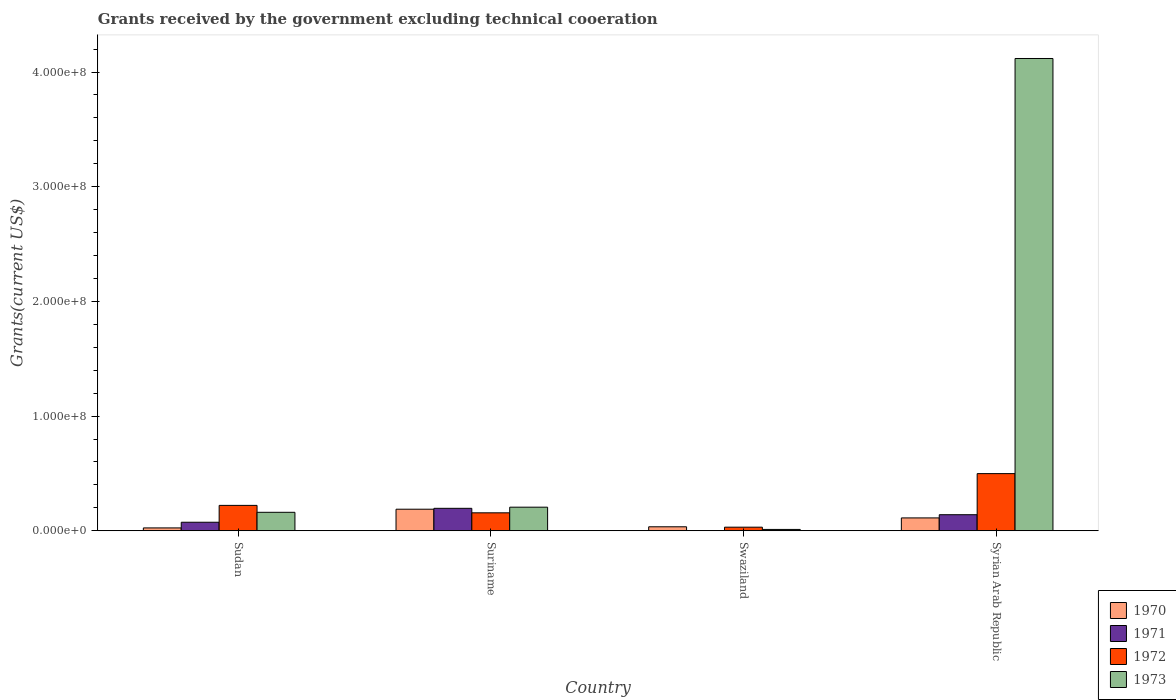How many different coloured bars are there?
Keep it short and to the point. 4. Are the number of bars per tick equal to the number of legend labels?
Your answer should be very brief. No. Are the number of bars on each tick of the X-axis equal?
Keep it short and to the point. No. How many bars are there on the 3rd tick from the left?
Provide a short and direct response. 3. How many bars are there on the 2nd tick from the right?
Keep it short and to the point. 3. What is the label of the 3rd group of bars from the left?
Provide a succinct answer. Swaziland. What is the total grants received by the government in 1973 in Syrian Arab Republic?
Your answer should be very brief. 4.12e+08. Across all countries, what is the maximum total grants received by the government in 1971?
Offer a terse response. 1.96e+07. Across all countries, what is the minimum total grants received by the government in 1972?
Give a very brief answer. 3.14e+06. In which country was the total grants received by the government in 1972 maximum?
Give a very brief answer. Syrian Arab Republic. What is the total total grants received by the government in 1970 in the graph?
Offer a terse response. 3.60e+07. What is the difference between the total grants received by the government in 1970 in Sudan and that in Swaziland?
Your answer should be very brief. -9.90e+05. What is the difference between the total grants received by the government in 1970 in Sudan and the total grants received by the government in 1972 in Syrian Arab Republic?
Your answer should be very brief. -4.74e+07. What is the average total grants received by the government in 1972 per country?
Keep it short and to the point. 2.27e+07. What is the difference between the total grants received by the government of/in 1970 and total grants received by the government of/in 1971 in Sudan?
Make the answer very short. -4.95e+06. What is the ratio of the total grants received by the government in 1970 in Sudan to that in Swaziland?
Ensure brevity in your answer.  0.72. Is the difference between the total grants received by the government in 1970 in Sudan and Syrian Arab Republic greater than the difference between the total grants received by the government in 1971 in Sudan and Syrian Arab Republic?
Provide a short and direct response. No. What is the difference between the highest and the second highest total grants received by the government in 1970?
Provide a succinct answer. 7.58e+06. What is the difference between the highest and the lowest total grants received by the government in 1971?
Your answer should be compact. 1.96e+07. Is the sum of the total grants received by the government in 1970 in Sudan and Swaziland greater than the maximum total grants received by the government in 1973 across all countries?
Make the answer very short. No. Are all the bars in the graph horizontal?
Keep it short and to the point. No. What is the difference between two consecutive major ticks on the Y-axis?
Your answer should be very brief. 1.00e+08. What is the title of the graph?
Keep it short and to the point. Grants received by the government excluding technical cooeration. What is the label or title of the Y-axis?
Give a very brief answer. Grants(current US$). What is the Grants(current US$) in 1970 in Sudan?
Your response must be concise. 2.50e+06. What is the Grants(current US$) in 1971 in Sudan?
Offer a terse response. 7.45e+06. What is the Grants(current US$) in 1972 in Sudan?
Offer a very short reply. 2.22e+07. What is the Grants(current US$) in 1973 in Sudan?
Make the answer very short. 1.61e+07. What is the Grants(current US$) of 1970 in Suriname?
Provide a short and direct response. 1.88e+07. What is the Grants(current US$) of 1971 in Suriname?
Provide a short and direct response. 1.96e+07. What is the Grants(current US$) in 1972 in Suriname?
Ensure brevity in your answer.  1.57e+07. What is the Grants(current US$) of 1973 in Suriname?
Offer a very short reply. 2.06e+07. What is the Grants(current US$) in 1970 in Swaziland?
Offer a terse response. 3.49e+06. What is the Grants(current US$) in 1972 in Swaziland?
Give a very brief answer. 3.14e+06. What is the Grants(current US$) in 1973 in Swaziland?
Your response must be concise. 1.18e+06. What is the Grants(current US$) of 1970 in Syrian Arab Republic?
Offer a very short reply. 1.12e+07. What is the Grants(current US$) in 1971 in Syrian Arab Republic?
Provide a short and direct response. 1.40e+07. What is the Grants(current US$) of 1972 in Syrian Arab Republic?
Give a very brief answer. 4.98e+07. What is the Grants(current US$) in 1973 in Syrian Arab Republic?
Ensure brevity in your answer.  4.12e+08. Across all countries, what is the maximum Grants(current US$) in 1970?
Provide a short and direct response. 1.88e+07. Across all countries, what is the maximum Grants(current US$) in 1971?
Your response must be concise. 1.96e+07. Across all countries, what is the maximum Grants(current US$) of 1972?
Your response must be concise. 4.98e+07. Across all countries, what is the maximum Grants(current US$) in 1973?
Give a very brief answer. 4.12e+08. Across all countries, what is the minimum Grants(current US$) in 1970?
Make the answer very short. 2.50e+06. Across all countries, what is the minimum Grants(current US$) in 1972?
Offer a very short reply. 3.14e+06. Across all countries, what is the minimum Grants(current US$) of 1973?
Keep it short and to the point. 1.18e+06. What is the total Grants(current US$) in 1970 in the graph?
Make the answer very short. 3.60e+07. What is the total Grants(current US$) of 1971 in the graph?
Keep it short and to the point. 4.10e+07. What is the total Grants(current US$) in 1972 in the graph?
Your response must be concise. 9.08e+07. What is the total Grants(current US$) of 1973 in the graph?
Your response must be concise. 4.50e+08. What is the difference between the Grants(current US$) of 1970 in Sudan and that in Suriname?
Your response must be concise. -1.63e+07. What is the difference between the Grants(current US$) in 1971 in Sudan and that in Suriname?
Offer a terse response. -1.21e+07. What is the difference between the Grants(current US$) of 1972 in Sudan and that in Suriname?
Make the answer very short. 6.49e+06. What is the difference between the Grants(current US$) in 1973 in Sudan and that in Suriname?
Offer a terse response. -4.46e+06. What is the difference between the Grants(current US$) in 1970 in Sudan and that in Swaziland?
Make the answer very short. -9.90e+05. What is the difference between the Grants(current US$) of 1972 in Sudan and that in Swaziland?
Ensure brevity in your answer.  1.90e+07. What is the difference between the Grants(current US$) of 1973 in Sudan and that in Swaziland?
Your answer should be compact. 1.49e+07. What is the difference between the Grants(current US$) of 1970 in Sudan and that in Syrian Arab Republic?
Your answer should be compact. -8.73e+06. What is the difference between the Grants(current US$) of 1971 in Sudan and that in Syrian Arab Republic?
Give a very brief answer. -6.56e+06. What is the difference between the Grants(current US$) of 1972 in Sudan and that in Syrian Arab Republic?
Offer a very short reply. -2.77e+07. What is the difference between the Grants(current US$) of 1973 in Sudan and that in Syrian Arab Republic?
Offer a very short reply. -3.96e+08. What is the difference between the Grants(current US$) of 1970 in Suriname and that in Swaziland?
Provide a succinct answer. 1.53e+07. What is the difference between the Grants(current US$) in 1972 in Suriname and that in Swaziland?
Keep it short and to the point. 1.25e+07. What is the difference between the Grants(current US$) in 1973 in Suriname and that in Swaziland?
Offer a very short reply. 1.94e+07. What is the difference between the Grants(current US$) of 1970 in Suriname and that in Syrian Arab Republic?
Offer a very short reply. 7.58e+06. What is the difference between the Grants(current US$) of 1971 in Suriname and that in Syrian Arab Republic?
Your response must be concise. 5.58e+06. What is the difference between the Grants(current US$) of 1972 in Suriname and that in Syrian Arab Republic?
Your answer should be compact. -3.42e+07. What is the difference between the Grants(current US$) in 1973 in Suriname and that in Syrian Arab Republic?
Keep it short and to the point. -3.91e+08. What is the difference between the Grants(current US$) in 1970 in Swaziland and that in Syrian Arab Republic?
Ensure brevity in your answer.  -7.74e+06. What is the difference between the Grants(current US$) in 1972 in Swaziland and that in Syrian Arab Republic?
Give a very brief answer. -4.67e+07. What is the difference between the Grants(current US$) in 1973 in Swaziland and that in Syrian Arab Republic?
Ensure brevity in your answer.  -4.11e+08. What is the difference between the Grants(current US$) of 1970 in Sudan and the Grants(current US$) of 1971 in Suriname?
Your answer should be very brief. -1.71e+07. What is the difference between the Grants(current US$) of 1970 in Sudan and the Grants(current US$) of 1972 in Suriname?
Make the answer very short. -1.32e+07. What is the difference between the Grants(current US$) of 1970 in Sudan and the Grants(current US$) of 1973 in Suriname?
Make the answer very short. -1.81e+07. What is the difference between the Grants(current US$) of 1971 in Sudan and the Grants(current US$) of 1972 in Suriname?
Your answer should be very brief. -8.21e+06. What is the difference between the Grants(current US$) of 1971 in Sudan and the Grants(current US$) of 1973 in Suriname?
Offer a very short reply. -1.31e+07. What is the difference between the Grants(current US$) in 1972 in Sudan and the Grants(current US$) in 1973 in Suriname?
Keep it short and to the point. 1.57e+06. What is the difference between the Grants(current US$) in 1970 in Sudan and the Grants(current US$) in 1972 in Swaziland?
Provide a short and direct response. -6.40e+05. What is the difference between the Grants(current US$) of 1970 in Sudan and the Grants(current US$) of 1973 in Swaziland?
Make the answer very short. 1.32e+06. What is the difference between the Grants(current US$) in 1971 in Sudan and the Grants(current US$) in 1972 in Swaziland?
Your response must be concise. 4.31e+06. What is the difference between the Grants(current US$) in 1971 in Sudan and the Grants(current US$) in 1973 in Swaziland?
Give a very brief answer. 6.27e+06. What is the difference between the Grants(current US$) of 1972 in Sudan and the Grants(current US$) of 1973 in Swaziland?
Provide a short and direct response. 2.10e+07. What is the difference between the Grants(current US$) of 1970 in Sudan and the Grants(current US$) of 1971 in Syrian Arab Republic?
Provide a succinct answer. -1.15e+07. What is the difference between the Grants(current US$) of 1970 in Sudan and the Grants(current US$) of 1972 in Syrian Arab Republic?
Your answer should be compact. -4.74e+07. What is the difference between the Grants(current US$) in 1970 in Sudan and the Grants(current US$) in 1973 in Syrian Arab Republic?
Keep it short and to the point. -4.09e+08. What is the difference between the Grants(current US$) of 1971 in Sudan and the Grants(current US$) of 1972 in Syrian Arab Republic?
Your answer should be compact. -4.24e+07. What is the difference between the Grants(current US$) of 1971 in Sudan and the Grants(current US$) of 1973 in Syrian Arab Republic?
Offer a terse response. -4.04e+08. What is the difference between the Grants(current US$) in 1972 in Sudan and the Grants(current US$) in 1973 in Syrian Arab Republic?
Your answer should be compact. -3.90e+08. What is the difference between the Grants(current US$) of 1970 in Suriname and the Grants(current US$) of 1972 in Swaziland?
Your answer should be very brief. 1.57e+07. What is the difference between the Grants(current US$) of 1970 in Suriname and the Grants(current US$) of 1973 in Swaziland?
Your answer should be compact. 1.76e+07. What is the difference between the Grants(current US$) in 1971 in Suriname and the Grants(current US$) in 1972 in Swaziland?
Offer a terse response. 1.64e+07. What is the difference between the Grants(current US$) in 1971 in Suriname and the Grants(current US$) in 1973 in Swaziland?
Give a very brief answer. 1.84e+07. What is the difference between the Grants(current US$) in 1972 in Suriname and the Grants(current US$) in 1973 in Swaziland?
Your answer should be very brief. 1.45e+07. What is the difference between the Grants(current US$) in 1970 in Suriname and the Grants(current US$) in 1971 in Syrian Arab Republic?
Your answer should be very brief. 4.80e+06. What is the difference between the Grants(current US$) of 1970 in Suriname and the Grants(current US$) of 1972 in Syrian Arab Republic?
Your response must be concise. -3.10e+07. What is the difference between the Grants(current US$) of 1970 in Suriname and the Grants(current US$) of 1973 in Syrian Arab Republic?
Ensure brevity in your answer.  -3.93e+08. What is the difference between the Grants(current US$) in 1971 in Suriname and the Grants(current US$) in 1972 in Syrian Arab Republic?
Your response must be concise. -3.03e+07. What is the difference between the Grants(current US$) in 1971 in Suriname and the Grants(current US$) in 1973 in Syrian Arab Republic?
Provide a short and direct response. -3.92e+08. What is the difference between the Grants(current US$) of 1972 in Suriname and the Grants(current US$) of 1973 in Syrian Arab Republic?
Your answer should be very brief. -3.96e+08. What is the difference between the Grants(current US$) of 1970 in Swaziland and the Grants(current US$) of 1971 in Syrian Arab Republic?
Offer a terse response. -1.05e+07. What is the difference between the Grants(current US$) in 1970 in Swaziland and the Grants(current US$) in 1972 in Syrian Arab Republic?
Provide a short and direct response. -4.64e+07. What is the difference between the Grants(current US$) in 1970 in Swaziland and the Grants(current US$) in 1973 in Syrian Arab Republic?
Ensure brevity in your answer.  -4.08e+08. What is the difference between the Grants(current US$) of 1972 in Swaziland and the Grants(current US$) of 1973 in Syrian Arab Republic?
Your answer should be very brief. -4.09e+08. What is the average Grants(current US$) of 1970 per country?
Offer a very short reply. 9.01e+06. What is the average Grants(current US$) in 1971 per country?
Your answer should be very brief. 1.03e+07. What is the average Grants(current US$) of 1972 per country?
Offer a very short reply. 2.27e+07. What is the average Grants(current US$) in 1973 per country?
Provide a succinct answer. 1.12e+08. What is the difference between the Grants(current US$) in 1970 and Grants(current US$) in 1971 in Sudan?
Your answer should be very brief. -4.95e+06. What is the difference between the Grants(current US$) of 1970 and Grants(current US$) of 1972 in Sudan?
Keep it short and to the point. -1.96e+07. What is the difference between the Grants(current US$) of 1970 and Grants(current US$) of 1973 in Sudan?
Your answer should be very brief. -1.36e+07. What is the difference between the Grants(current US$) of 1971 and Grants(current US$) of 1972 in Sudan?
Provide a short and direct response. -1.47e+07. What is the difference between the Grants(current US$) in 1971 and Grants(current US$) in 1973 in Sudan?
Provide a succinct answer. -8.67e+06. What is the difference between the Grants(current US$) of 1972 and Grants(current US$) of 1973 in Sudan?
Provide a short and direct response. 6.03e+06. What is the difference between the Grants(current US$) in 1970 and Grants(current US$) in 1971 in Suriname?
Ensure brevity in your answer.  -7.80e+05. What is the difference between the Grants(current US$) in 1970 and Grants(current US$) in 1972 in Suriname?
Ensure brevity in your answer.  3.15e+06. What is the difference between the Grants(current US$) of 1970 and Grants(current US$) of 1973 in Suriname?
Your response must be concise. -1.77e+06. What is the difference between the Grants(current US$) of 1971 and Grants(current US$) of 1972 in Suriname?
Offer a terse response. 3.93e+06. What is the difference between the Grants(current US$) in 1971 and Grants(current US$) in 1973 in Suriname?
Provide a succinct answer. -9.90e+05. What is the difference between the Grants(current US$) of 1972 and Grants(current US$) of 1973 in Suriname?
Give a very brief answer. -4.92e+06. What is the difference between the Grants(current US$) of 1970 and Grants(current US$) of 1972 in Swaziland?
Provide a short and direct response. 3.50e+05. What is the difference between the Grants(current US$) of 1970 and Grants(current US$) of 1973 in Swaziland?
Your answer should be compact. 2.31e+06. What is the difference between the Grants(current US$) in 1972 and Grants(current US$) in 1973 in Swaziland?
Give a very brief answer. 1.96e+06. What is the difference between the Grants(current US$) of 1970 and Grants(current US$) of 1971 in Syrian Arab Republic?
Your answer should be very brief. -2.78e+06. What is the difference between the Grants(current US$) of 1970 and Grants(current US$) of 1972 in Syrian Arab Republic?
Ensure brevity in your answer.  -3.86e+07. What is the difference between the Grants(current US$) of 1970 and Grants(current US$) of 1973 in Syrian Arab Republic?
Ensure brevity in your answer.  -4.01e+08. What is the difference between the Grants(current US$) in 1971 and Grants(current US$) in 1972 in Syrian Arab Republic?
Keep it short and to the point. -3.58e+07. What is the difference between the Grants(current US$) of 1971 and Grants(current US$) of 1973 in Syrian Arab Republic?
Make the answer very short. -3.98e+08. What is the difference between the Grants(current US$) of 1972 and Grants(current US$) of 1973 in Syrian Arab Republic?
Provide a succinct answer. -3.62e+08. What is the ratio of the Grants(current US$) in 1970 in Sudan to that in Suriname?
Make the answer very short. 0.13. What is the ratio of the Grants(current US$) in 1971 in Sudan to that in Suriname?
Offer a very short reply. 0.38. What is the ratio of the Grants(current US$) of 1972 in Sudan to that in Suriname?
Offer a terse response. 1.41. What is the ratio of the Grants(current US$) of 1973 in Sudan to that in Suriname?
Your response must be concise. 0.78. What is the ratio of the Grants(current US$) of 1970 in Sudan to that in Swaziland?
Provide a short and direct response. 0.72. What is the ratio of the Grants(current US$) of 1972 in Sudan to that in Swaziland?
Ensure brevity in your answer.  7.05. What is the ratio of the Grants(current US$) in 1973 in Sudan to that in Swaziland?
Make the answer very short. 13.66. What is the ratio of the Grants(current US$) of 1970 in Sudan to that in Syrian Arab Republic?
Provide a succinct answer. 0.22. What is the ratio of the Grants(current US$) of 1971 in Sudan to that in Syrian Arab Republic?
Give a very brief answer. 0.53. What is the ratio of the Grants(current US$) in 1972 in Sudan to that in Syrian Arab Republic?
Give a very brief answer. 0.44. What is the ratio of the Grants(current US$) of 1973 in Sudan to that in Syrian Arab Republic?
Make the answer very short. 0.04. What is the ratio of the Grants(current US$) in 1970 in Suriname to that in Swaziland?
Make the answer very short. 5.39. What is the ratio of the Grants(current US$) of 1972 in Suriname to that in Swaziland?
Give a very brief answer. 4.99. What is the ratio of the Grants(current US$) of 1973 in Suriname to that in Swaziland?
Your response must be concise. 17.44. What is the ratio of the Grants(current US$) in 1970 in Suriname to that in Syrian Arab Republic?
Ensure brevity in your answer.  1.68. What is the ratio of the Grants(current US$) in 1971 in Suriname to that in Syrian Arab Republic?
Offer a very short reply. 1.4. What is the ratio of the Grants(current US$) of 1972 in Suriname to that in Syrian Arab Republic?
Keep it short and to the point. 0.31. What is the ratio of the Grants(current US$) of 1970 in Swaziland to that in Syrian Arab Republic?
Your response must be concise. 0.31. What is the ratio of the Grants(current US$) in 1972 in Swaziland to that in Syrian Arab Republic?
Your answer should be compact. 0.06. What is the ratio of the Grants(current US$) of 1973 in Swaziland to that in Syrian Arab Republic?
Offer a very short reply. 0. What is the difference between the highest and the second highest Grants(current US$) of 1970?
Offer a very short reply. 7.58e+06. What is the difference between the highest and the second highest Grants(current US$) in 1971?
Offer a terse response. 5.58e+06. What is the difference between the highest and the second highest Grants(current US$) of 1972?
Keep it short and to the point. 2.77e+07. What is the difference between the highest and the second highest Grants(current US$) in 1973?
Provide a succinct answer. 3.91e+08. What is the difference between the highest and the lowest Grants(current US$) of 1970?
Give a very brief answer. 1.63e+07. What is the difference between the highest and the lowest Grants(current US$) in 1971?
Provide a succinct answer. 1.96e+07. What is the difference between the highest and the lowest Grants(current US$) of 1972?
Make the answer very short. 4.67e+07. What is the difference between the highest and the lowest Grants(current US$) of 1973?
Your answer should be compact. 4.11e+08. 